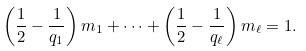<formula> <loc_0><loc_0><loc_500><loc_500>\left ( \frac { 1 } { 2 } - \frac { 1 } { q _ { 1 } } \right ) m _ { 1 } + \cdots + \left ( \frac { 1 } { 2 } - \frac { 1 } { q _ { \ell } } \right ) m _ { \ell } = 1 .</formula> 